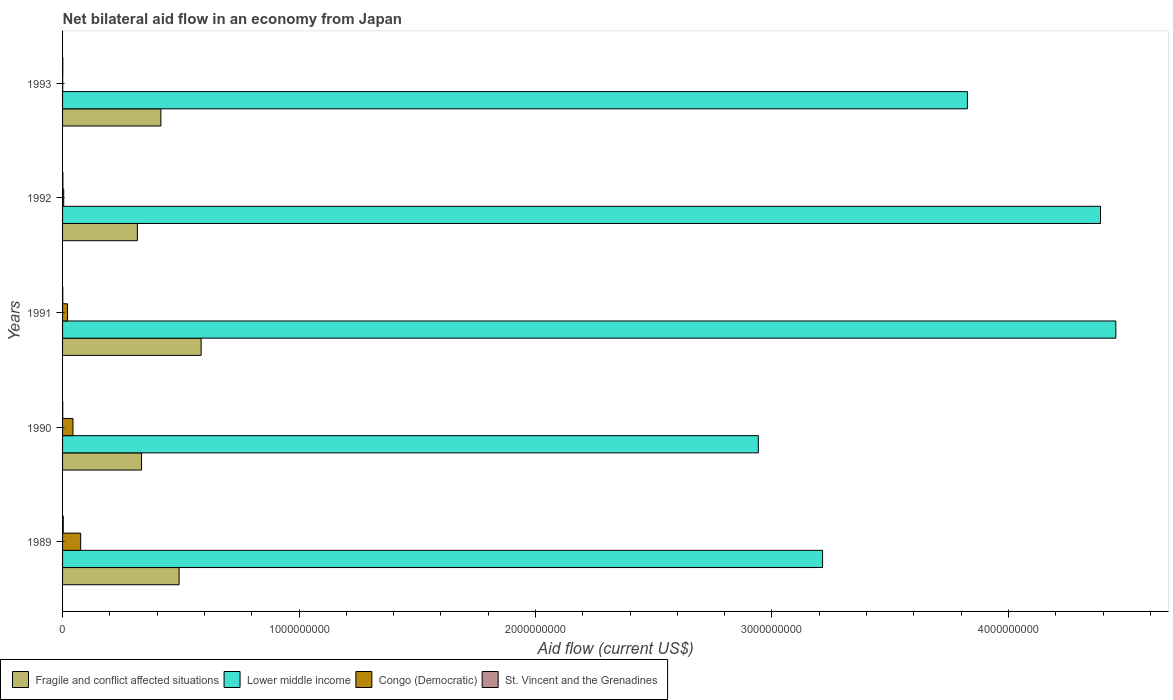How many different coloured bars are there?
Your answer should be compact. 4. How many groups of bars are there?
Offer a terse response. 5. Are the number of bars per tick equal to the number of legend labels?
Your answer should be very brief. Yes. Are the number of bars on each tick of the Y-axis equal?
Your answer should be compact. Yes. In how many cases, is the number of bars for a given year not equal to the number of legend labels?
Keep it short and to the point. 0. What is the net bilateral aid flow in Lower middle income in 1993?
Make the answer very short. 3.83e+09. Across all years, what is the maximum net bilateral aid flow in Congo (Democratic)?
Offer a terse response. 7.66e+07. Across all years, what is the minimum net bilateral aid flow in Fragile and conflict affected situations?
Your answer should be very brief. 3.16e+08. What is the total net bilateral aid flow in Congo (Democratic) in the graph?
Offer a very short reply. 1.47e+08. What is the difference between the net bilateral aid flow in Fragile and conflict affected situations in 1989 and that in 1993?
Your response must be concise. 7.71e+07. What is the difference between the net bilateral aid flow in Congo (Democratic) in 1990 and the net bilateral aid flow in St. Vincent and the Grenadines in 1993?
Your answer should be compact. 4.31e+07. What is the average net bilateral aid flow in Fragile and conflict affected situations per year?
Provide a succinct answer. 4.29e+08. In the year 1990, what is the difference between the net bilateral aid flow in St. Vincent and the Grenadines and net bilateral aid flow in Fragile and conflict affected situations?
Provide a succinct answer. -3.33e+08. In how many years, is the net bilateral aid flow in Lower middle income greater than 4200000000 US$?
Your answer should be very brief. 2. What is the ratio of the net bilateral aid flow in Congo (Democratic) in 1990 to that in 1992?
Make the answer very short. 9.22. Is the net bilateral aid flow in St. Vincent and the Grenadines in 1990 less than that in 1993?
Give a very brief answer. Yes. Is the difference between the net bilateral aid flow in St. Vincent and the Grenadines in 1991 and 1993 greater than the difference between the net bilateral aid flow in Fragile and conflict affected situations in 1991 and 1993?
Give a very brief answer. No. What is the difference between the highest and the second highest net bilateral aid flow in Fragile and conflict affected situations?
Offer a very short reply. 9.31e+07. What is the difference between the highest and the lowest net bilateral aid flow in Fragile and conflict affected situations?
Provide a short and direct response. 2.70e+08. Is the sum of the net bilateral aid flow in Lower middle income in 1989 and 1993 greater than the maximum net bilateral aid flow in St. Vincent and the Grenadines across all years?
Your response must be concise. Yes. Is it the case that in every year, the sum of the net bilateral aid flow in St. Vincent and the Grenadines and net bilateral aid flow in Congo (Democratic) is greater than the sum of net bilateral aid flow in Fragile and conflict affected situations and net bilateral aid flow in Lower middle income?
Your response must be concise. No. What does the 3rd bar from the top in 1991 represents?
Give a very brief answer. Lower middle income. What does the 1st bar from the bottom in 1992 represents?
Provide a short and direct response. Fragile and conflict affected situations. How many bars are there?
Your answer should be compact. 20. What is the difference between two consecutive major ticks on the X-axis?
Offer a terse response. 1.00e+09. Does the graph contain any zero values?
Give a very brief answer. No. How many legend labels are there?
Ensure brevity in your answer.  4. What is the title of the graph?
Your answer should be compact. Net bilateral aid flow in an economy from Japan. Does "Sweden" appear as one of the legend labels in the graph?
Your response must be concise. No. What is the Aid flow (current US$) of Fragile and conflict affected situations in 1989?
Keep it short and to the point. 4.93e+08. What is the Aid flow (current US$) of Lower middle income in 1989?
Your answer should be compact. 3.21e+09. What is the Aid flow (current US$) of Congo (Democratic) in 1989?
Offer a very short reply. 7.66e+07. What is the Aid flow (current US$) in St. Vincent and the Grenadines in 1989?
Make the answer very short. 2.97e+06. What is the Aid flow (current US$) of Fragile and conflict affected situations in 1990?
Make the answer very short. 3.34e+08. What is the Aid flow (current US$) in Lower middle income in 1990?
Provide a short and direct response. 2.94e+09. What is the Aid flow (current US$) of Congo (Democratic) in 1990?
Keep it short and to the point. 4.41e+07. What is the Aid flow (current US$) of St. Vincent and the Grenadines in 1990?
Offer a very short reply. 8.00e+05. What is the Aid flow (current US$) in Fragile and conflict affected situations in 1991?
Your answer should be very brief. 5.86e+08. What is the Aid flow (current US$) of Lower middle income in 1991?
Offer a very short reply. 4.45e+09. What is the Aid flow (current US$) of Congo (Democratic) in 1991?
Your answer should be compact. 2.10e+07. What is the Aid flow (current US$) in St. Vincent and the Grenadines in 1991?
Keep it short and to the point. 8.90e+05. What is the Aid flow (current US$) of Fragile and conflict affected situations in 1992?
Your answer should be compact. 3.16e+08. What is the Aid flow (current US$) in Lower middle income in 1992?
Give a very brief answer. 4.39e+09. What is the Aid flow (current US$) in Congo (Democratic) in 1992?
Your answer should be compact. 4.78e+06. What is the Aid flow (current US$) of St. Vincent and the Grenadines in 1992?
Keep it short and to the point. 1.39e+06. What is the Aid flow (current US$) in Fragile and conflict affected situations in 1993?
Your response must be concise. 4.16e+08. What is the Aid flow (current US$) in Lower middle income in 1993?
Make the answer very short. 3.83e+09. What is the Aid flow (current US$) in Congo (Democratic) in 1993?
Ensure brevity in your answer.  5.10e+05. What is the Aid flow (current US$) in St. Vincent and the Grenadines in 1993?
Provide a succinct answer. 9.90e+05. Across all years, what is the maximum Aid flow (current US$) in Fragile and conflict affected situations?
Give a very brief answer. 5.86e+08. Across all years, what is the maximum Aid flow (current US$) of Lower middle income?
Keep it short and to the point. 4.45e+09. Across all years, what is the maximum Aid flow (current US$) of Congo (Democratic)?
Your answer should be compact. 7.66e+07. Across all years, what is the maximum Aid flow (current US$) in St. Vincent and the Grenadines?
Make the answer very short. 2.97e+06. Across all years, what is the minimum Aid flow (current US$) in Fragile and conflict affected situations?
Offer a terse response. 3.16e+08. Across all years, what is the minimum Aid flow (current US$) in Lower middle income?
Make the answer very short. 2.94e+09. Across all years, what is the minimum Aid flow (current US$) in Congo (Democratic)?
Your answer should be compact. 5.10e+05. Across all years, what is the minimum Aid flow (current US$) of St. Vincent and the Grenadines?
Offer a terse response. 8.00e+05. What is the total Aid flow (current US$) in Fragile and conflict affected situations in the graph?
Ensure brevity in your answer.  2.14e+09. What is the total Aid flow (current US$) in Lower middle income in the graph?
Offer a terse response. 1.88e+1. What is the total Aid flow (current US$) of Congo (Democratic) in the graph?
Make the answer very short. 1.47e+08. What is the total Aid flow (current US$) in St. Vincent and the Grenadines in the graph?
Make the answer very short. 7.04e+06. What is the difference between the Aid flow (current US$) in Fragile and conflict affected situations in 1989 and that in 1990?
Offer a terse response. 1.59e+08. What is the difference between the Aid flow (current US$) in Lower middle income in 1989 and that in 1990?
Offer a very short reply. 2.72e+08. What is the difference between the Aid flow (current US$) in Congo (Democratic) in 1989 and that in 1990?
Give a very brief answer. 3.25e+07. What is the difference between the Aid flow (current US$) of St. Vincent and the Grenadines in 1989 and that in 1990?
Make the answer very short. 2.17e+06. What is the difference between the Aid flow (current US$) of Fragile and conflict affected situations in 1989 and that in 1991?
Your response must be concise. -9.31e+07. What is the difference between the Aid flow (current US$) in Lower middle income in 1989 and that in 1991?
Provide a short and direct response. -1.24e+09. What is the difference between the Aid flow (current US$) of Congo (Democratic) in 1989 and that in 1991?
Your response must be concise. 5.55e+07. What is the difference between the Aid flow (current US$) of St. Vincent and the Grenadines in 1989 and that in 1991?
Keep it short and to the point. 2.08e+06. What is the difference between the Aid flow (current US$) in Fragile and conflict affected situations in 1989 and that in 1992?
Ensure brevity in your answer.  1.77e+08. What is the difference between the Aid flow (current US$) of Lower middle income in 1989 and that in 1992?
Offer a very short reply. -1.18e+09. What is the difference between the Aid flow (current US$) of Congo (Democratic) in 1989 and that in 1992?
Ensure brevity in your answer.  7.18e+07. What is the difference between the Aid flow (current US$) of St. Vincent and the Grenadines in 1989 and that in 1992?
Make the answer very short. 1.58e+06. What is the difference between the Aid flow (current US$) of Fragile and conflict affected situations in 1989 and that in 1993?
Offer a terse response. 7.71e+07. What is the difference between the Aid flow (current US$) in Lower middle income in 1989 and that in 1993?
Make the answer very short. -6.12e+08. What is the difference between the Aid flow (current US$) of Congo (Democratic) in 1989 and that in 1993?
Your answer should be compact. 7.60e+07. What is the difference between the Aid flow (current US$) of St. Vincent and the Grenadines in 1989 and that in 1993?
Give a very brief answer. 1.98e+06. What is the difference between the Aid flow (current US$) in Fragile and conflict affected situations in 1990 and that in 1991?
Give a very brief answer. -2.52e+08. What is the difference between the Aid flow (current US$) in Lower middle income in 1990 and that in 1991?
Offer a very short reply. -1.51e+09. What is the difference between the Aid flow (current US$) in Congo (Democratic) in 1990 and that in 1991?
Your answer should be compact. 2.31e+07. What is the difference between the Aid flow (current US$) of Fragile and conflict affected situations in 1990 and that in 1992?
Your answer should be compact. 1.76e+07. What is the difference between the Aid flow (current US$) in Lower middle income in 1990 and that in 1992?
Make the answer very short. -1.45e+09. What is the difference between the Aid flow (current US$) of Congo (Democratic) in 1990 and that in 1992?
Keep it short and to the point. 3.93e+07. What is the difference between the Aid flow (current US$) in St. Vincent and the Grenadines in 1990 and that in 1992?
Offer a terse response. -5.90e+05. What is the difference between the Aid flow (current US$) in Fragile and conflict affected situations in 1990 and that in 1993?
Ensure brevity in your answer.  -8.18e+07. What is the difference between the Aid flow (current US$) in Lower middle income in 1990 and that in 1993?
Your answer should be very brief. -8.84e+08. What is the difference between the Aid flow (current US$) of Congo (Democratic) in 1990 and that in 1993?
Your answer should be very brief. 4.36e+07. What is the difference between the Aid flow (current US$) of Fragile and conflict affected situations in 1991 and that in 1992?
Ensure brevity in your answer.  2.70e+08. What is the difference between the Aid flow (current US$) of Lower middle income in 1991 and that in 1992?
Your response must be concise. 6.48e+07. What is the difference between the Aid flow (current US$) in Congo (Democratic) in 1991 and that in 1992?
Give a very brief answer. 1.62e+07. What is the difference between the Aid flow (current US$) of St. Vincent and the Grenadines in 1991 and that in 1992?
Provide a short and direct response. -5.00e+05. What is the difference between the Aid flow (current US$) in Fragile and conflict affected situations in 1991 and that in 1993?
Your answer should be very brief. 1.70e+08. What is the difference between the Aid flow (current US$) in Lower middle income in 1991 and that in 1993?
Your answer should be very brief. 6.28e+08. What is the difference between the Aid flow (current US$) of Congo (Democratic) in 1991 and that in 1993?
Your response must be concise. 2.05e+07. What is the difference between the Aid flow (current US$) of St. Vincent and the Grenadines in 1991 and that in 1993?
Ensure brevity in your answer.  -1.00e+05. What is the difference between the Aid flow (current US$) in Fragile and conflict affected situations in 1992 and that in 1993?
Your answer should be compact. -9.94e+07. What is the difference between the Aid flow (current US$) in Lower middle income in 1992 and that in 1993?
Offer a very short reply. 5.63e+08. What is the difference between the Aid flow (current US$) in Congo (Democratic) in 1992 and that in 1993?
Your answer should be very brief. 4.27e+06. What is the difference between the Aid flow (current US$) in St. Vincent and the Grenadines in 1992 and that in 1993?
Provide a succinct answer. 4.00e+05. What is the difference between the Aid flow (current US$) in Fragile and conflict affected situations in 1989 and the Aid flow (current US$) in Lower middle income in 1990?
Provide a short and direct response. -2.45e+09. What is the difference between the Aid flow (current US$) of Fragile and conflict affected situations in 1989 and the Aid flow (current US$) of Congo (Democratic) in 1990?
Offer a terse response. 4.49e+08. What is the difference between the Aid flow (current US$) in Fragile and conflict affected situations in 1989 and the Aid flow (current US$) in St. Vincent and the Grenadines in 1990?
Ensure brevity in your answer.  4.92e+08. What is the difference between the Aid flow (current US$) in Lower middle income in 1989 and the Aid flow (current US$) in Congo (Democratic) in 1990?
Your response must be concise. 3.17e+09. What is the difference between the Aid flow (current US$) of Lower middle income in 1989 and the Aid flow (current US$) of St. Vincent and the Grenadines in 1990?
Keep it short and to the point. 3.21e+09. What is the difference between the Aid flow (current US$) in Congo (Democratic) in 1989 and the Aid flow (current US$) in St. Vincent and the Grenadines in 1990?
Offer a terse response. 7.58e+07. What is the difference between the Aid flow (current US$) of Fragile and conflict affected situations in 1989 and the Aid flow (current US$) of Lower middle income in 1991?
Offer a very short reply. -3.96e+09. What is the difference between the Aid flow (current US$) of Fragile and conflict affected situations in 1989 and the Aid flow (current US$) of Congo (Democratic) in 1991?
Your answer should be very brief. 4.72e+08. What is the difference between the Aid flow (current US$) of Fragile and conflict affected situations in 1989 and the Aid flow (current US$) of St. Vincent and the Grenadines in 1991?
Give a very brief answer. 4.92e+08. What is the difference between the Aid flow (current US$) of Lower middle income in 1989 and the Aid flow (current US$) of Congo (Democratic) in 1991?
Give a very brief answer. 3.19e+09. What is the difference between the Aid flow (current US$) in Lower middle income in 1989 and the Aid flow (current US$) in St. Vincent and the Grenadines in 1991?
Make the answer very short. 3.21e+09. What is the difference between the Aid flow (current US$) in Congo (Democratic) in 1989 and the Aid flow (current US$) in St. Vincent and the Grenadines in 1991?
Ensure brevity in your answer.  7.57e+07. What is the difference between the Aid flow (current US$) of Fragile and conflict affected situations in 1989 and the Aid flow (current US$) of Lower middle income in 1992?
Provide a short and direct response. -3.90e+09. What is the difference between the Aid flow (current US$) in Fragile and conflict affected situations in 1989 and the Aid flow (current US$) in Congo (Democratic) in 1992?
Ensure brevity in your answer.  4.88e+08. What is the difference between the Aid flow (current US$) of Fragile and conflict affected situations in 1989 and the Aid flow (current US$) of St. Vincent and the Grenadines in 1992?
Your response must be concise. 4.91e+08. What is the difference between the Aid flow (current US$) of Lower middle income in 1989 and the Aid flow (current US$) of Congo (Democratic) in 1992?
Your answer should be compact. 3.21e+09. What is the difference between the Aid flow (current US$) of Lower middle income in 1989 and the Aid flow (current US$) of St. Vincent and the Grenadines in 1992?
Provide a short and direct response. 3.21e+09. What is the difference between the Aid flow (current US$) in Congo (Democratic) in 1989 and the Aid flow (current US$) in St. Vincent and the Grenadines in 1992?
Your answer should be compact. 7.52e+07. What is the difference between the Aid flow (current US$) in Fragile and conflict affected situations in 1989 and the Aid flow (current US$) in Lower middle income in 1993?
Offer a terse response. -3.33e+09. What is the difference between the Aid flow (current US$) of Fragile and conflict affected situations in 1989 and the Aid flow (current US$) of Congo (Democratic) in 1993?
Keep it short and to the point. 4.92e+08. What is the difference between the Aid flow (current US$) of Fragile and conflict affected situations in 1989 and the Aid flow (current US$) of St. Vincent and the Grenadines in 1993?
Keep it short and to the point. 4.92e+08. What is the difference between the Aid flow (current US$) in Lower middle income in 1989 and the Aid flow (current US$) in Congo (Democratic) in 1993?
Provide a short and direct response. 3.21e+09. What is the difference between the Aid flow (current US$) in Lower middle income in 1989 and the Aid flow (current US$) in St. Vincent and the Grenadines in 1993?
Provide a succinct answer. 3.21e+09. What is the difference between the Aid flow (current US$) of Congo (Democratic) in 1989 and the Aid flow (current US$) of St. Vincent and the Grenadines in 1993?
Offer a very short reply. 7.56e+07. What is the difference between the Aid flow (current US$) of Fragile and conflict affected situations in 1990 and the Aid flow (current US$) of Lower middle income in 1991?
Make the answer very short. -4.12e+09. What is the difference between the Aid flow (current US$) in Fragile and conflict affected situations in 1990 and the Aid flow (current US$) in Congo (Democratic) in 1991?
Your response must be concise. 3.13e+08. What is the difference between the Aid flow (current US$) of Fragile and conflict affected situations in 1990 and the Aid flow (current US$) of St. Vincent and the Grenadines in 1991?
Your answer should be very brief. 3.33e+08. What is the difference between the Aid flow (current US$) of Lower middle income in 1990 and the Aid flow (current US$) of Congo (Democratic) in 1991?
Offer a terse response. 2.92e+09. What is the difference between the Aid flow (current US$) in Lower middle income in 1990 and the Aid flow (current US$) in St. Vincent and the Grenadines in 1991?
Keep it short and to the point. 2.94e+09. What is the difference between the Aid flow (current US$) of Congo (Democratic) in 1990 and the Aid flow (current US$) of St. Vincent and the Grenadines in 1991?
Keep it short and to the point. 4.32e+07. What is the difference between the Aid flow (current US$) of Fragile and conflict affected situations in 1990 and the Aid flow (current US$) of Lower middle income in 1992?
Keep it short and to the point. -4.06e+09. What is the difference between the Aid flow (current US$) of Fragile and conflict affected situations in 1990 and the Aid flow (current US$) of Congo (Democratic) in 1992?
Give a very brief answer. 3.29e+08. What is the difference between the Aid flow (current US$) of Fragile and conflict affected situations in 1990 and the Aid flow (current US$) of St. Vincent and the Grenadines in 1992?
Your answer should be very brief. 3.33e+08. What is the difference between the Aid flow (current US$) of Lower middle income in 1990 and the Aid flow (current US$) of Congo (Democratic) in 1992?
Provide a succinct answer. 2.94e+09. What is the difference between the Aid flow (current US$) of Lower middle income in 1990 and the Aid flow (current US$) of St. Vincent and the Grenadines in 1992?
Keep it short and to the point. 2.94e+09. What is the difference between the Aid flow (current US$) of Congo (Democratic) in 1990 and the Aid flow (current US$) of St. Vincent and the Grenadines in 1992?
Offer a very short reply. 4.27e+07. What is the difference between the Aid flow (current US$) in Fragile and conflict affected situations in 1990 and the Aid flow (current US$) in Lower middle income in 1993?
Your answer should be compact. -3.49e+09. What is the difference between the Aid flow (current US$) in Fragile and conflict affected situations in 1990 and the Aid flow (current US$) in Congo (Democratic) in 1993?
Offer a terse response. 3.33e+08. What is the difference between the Aid flow (current US$) of Fragile and conflict affected situations in 1990 and the Aid flow (current US$) of St. Vincent and the Grenadines in 1993?
Keep it short and to the point. 3.33e+08. What is the difference between the Aid flow (current US$) in Lower middle income in 1990 and the Aid flow (current US$) in Congo (Democratic) in 1993?
Your answer should be compact. 2.94e+09. What is the difference between the Aid flow (current US$) in Lower middle income in 1990 and the Aid flow (current US$) in St. Vincent and the Grenadines in 1993?
Ensure brevity in your answer.  2.94e+09. What is the difference between the Aid flow (current US$) in Congo (Democratic) in 1990 and the Aid flow (current US$) in St. Vincent and the Grenadines in 1993?
Make the answer very short. 4.31e+07. What is the difference between the Aid flow (current US$) of Fragile and conflict affected situations in 1991 and the Aid flow (current US$) of Lower middle income in 1992?
Provide a short and direct response. -3.80e+09. What is the difference between the Aid flow (current US$) of Fragile and conflict affected situations in 1991 and the Aid flow (current US$) of Congo (Democratic) in 1992?
Provide a short and direct response. 5.81e+08. What is the difference between the Aid flow (current US$) in Fragile and conflict affected situations in 1991 and the Aid flow (current US$) in St. Vincent and the Grenadines in 1992?
Keep it short and to the point. 5.85e+08. What is the difference between the Aid flow (current US$) of Lower middle income in 1991 and the Aid flow (current US$) of Congo (Democratic) in 1992?
Give a very brief answer. 4.45e+09. What is the difference between the Aid flow (current US$) in Lower middle income in 1991 and the Aid flow (current US$) in St. Vincent and the Grenadines in 1992?
Your answer should be compact. 4.45e+09. What is the difference between the Aid flow (current US$) in Congo (Democratic) in 1991 and the Aid flow (current US$) in St. Vincent and the Grenadines in 1992?
Provide a short and direct response. 1.96e+07. What is the difference between the Aid flow (current US$) in Fragile and conflict affected situations in 1991 and the Aid flow (current US$) in Lower middle income in 1993?
Offer a terse response. -3.24e+09. What is the difference between the Aid flow (current US$) of Fragile and conflict affected situations in 1991 and the Aid flow (current US$) of Congo (Democratic) in 1993?
Your answer should be compact. 5.85e+08. What is the difference between the Aid flow (current US$) in Fragile and conflict affected situations in 1991 and the Aid flow (current US$) in St. Vincent and the Grenadines in 1993?
Provide a short and direct response. 5.85e+08. What is the difference between the Aid flow (current US$) of Lower middle income in 1991 and the Aid flow (current US$) of Congo (Democratic) in 1993?
Offer a terse response. 4.45e+09. What is the difference between the Aid flow (current US$) of Lower middle income in 1991 and the Aid flow (current US$) of St. Vincent and the Grenadines in 1993?
Provide a succinct answer. 4.45e+09. What is the difference between the Aid flow (current US$) of Congo (Democratic) in 1991 and the Aid flow (current US$) of St. Vincent and the Grenadines in 1993?
Give a very brief answer. 2.00e+07. What is the difference between the Aid flow (current US$) of Fragile and conflict affected situations in 1992 and the Aid flow (current US$) of Lower middle income in 1993?
Make the answer very short. -3.51e+09. What is the difference between the Aid flow (current US$) in Fragile and conflict affected situations in 1992 and the Aid flow (current US$) in Congo (Democratic) in 1993?
Provide a short and direct response. 3.16e+08. What is the difference between the Aid flow (current US$) of Fragile and conflict affected situations in 1992 and the Aid flow (current US$) of St. Vincent and the Grenadines in 1993?
Your answer should be compact. 3.15e+08. What is the difference between the Aid flow (current US$) in Lower middle income in 1992 and the Aid flow (current US$) in Congo (Democratic) in 1993?
Make the answer very short. 4.39e+09. What is the difference between the Aid flow (current US$) of Lower middle income in 1992 and the Aid flow (current US$) of St. Vincent and the Grenadines in 1993?
Offer a terse response. 4.39e+09. What is the difference between the Aid flow (current US$) in Congo (Democratic) in 1992 and the Aid flow (current US$) in St. Vincent and the Grenadines in 1993?
Your answer should be compact. 3.79e+06. What is the average Aid flow (current US$) in Fragile and conflict affected situations per year?
Your response must be concise. 4.29e+08. What is the average Aid flow (current US$) in Lower middle income per year?
Your answer should be compact. 3.77e+09. What is the average Aid flow (current US$) in Congo (Democratic) per year?
Make the answer very short. 2.94e+07. What is the average Aid flow (current US$) in St. Vincent and the Grenadines per year?
Your answer should be compact. 1.41e+06. In the year 1989, what is the difference between the Aid flow (current US$) of Fragile and conflict affected situations and Aid flow (current US$) of Lower middle income?
Provide a succinct answer. -2.72e+09. In the year 1989, what is the difference between the Aid flow (current US$) of Fragile and conflict affected situations and Aid flow (current US$) of Congo (Democratic)?
Your response must be concise. 4.16e+08. In the year 1989, what is the difference between the Aid flow (current US$) in Fragile and conflict affected situations and Aid flow (current US$) in St. Vincent and the Grenadines?
Provide a short and direct response. 4.90e+08. In the year 1989, what is the difference between the Aid flow (current US$) in Lower middle income and Aid flow (current US$) in Congo (Democratic)?
Ensure brevity in your answer.  3.14e+09. In the year 1989, what is the difference between the Aid flow (current US$) in Lower middle income and Aid flow (current US$) in St. Vincent and the Grenadines?
Your answer should be very brief. 3.21e+09. In the year 1989, what is the difference between the Aid flow (current US$) of Congo (Democratic) and Aid flow (current US$) of St. Vincent and the Grenadines?
Keep it short and to the point. 7.36e+07. In the year 1990, what is the difference between the Aid flow (current US$) in Fragile and conflict affected situations and Aid flow (current US$) in Lower middle income?
Your response must be concise. -2.61e+09. In the year 1990, what is the difference between the Aid flow (current US$) of Fragile and conflict affected situations and Aid flow (current US$) of Congo (Democratic)?
Your response must be concise. 2.90e+08. In the year 1990, what is the difference between the Aid flow (current US$) in Fragile and conflict affected situations and Aid flow (current US$) in St. Vincent and the Grenadines?
Provide a short and direct response. 3.33e+08. In the year 1990, what is the difference between the Aid flow (current US$) of Lower middle income and Aid flow (current US$) of Congo (Democratic)?
Provide a succinct answer. 2.90e+09. In the year 1990, what is the difference between the Aid flow (current US$) of Lower middle income and Aid flow (current US$) of St. Vincent and the Grenadines?
Give a very brief answer. 2.94e+09. In the year 1990, what is the difference between the Aid flow (current US$) of Congo (Democratic) and Aid flow (current US$) of St. Vincent and the Grenadines?
Give a very brief answer. 4.33e+07. In the year 1991, what is the difference between the Aid flow (current US$) of Fragile and conflict affected situations and Aid flow (current US$) of Lower middle income?
Give a very brief answer. -3.87e+09. In the year 1991, what is the difference between the Aid flow (current US$) in Fragile and conflict affected situations and Aid flow (current US$) in Congo (Democratic)?
Give a very brief answer. 5.65e+08. In the year 1991, what is the difference between the Aid flow (current US$) in Fragile and conflict affected situations and Aid flow (current US$) in St. Vincent and the Grenadines?
Give a very brief answer. 5.85e+08. In the year 1991, what is the difference between the Aid flow (current US$) in Lower middle income and Aid flow (current US$) in Congo (Democratic)?
Offer a very short reply. 4.43e+09. In the year 1991, what is the difference between the Aid flow (current US$) of Lower middle income and Aid flow (current US$) of St. Vincent and the Grenadines?
Your answer should be compact. 4.45e+09. In the year 1991, what is the difference between the Aid flow (current US$) of Congo (Democratic) and Aid flow (current US$) of St. Vincent and the Grenadines?
Provide a short and direct response. 2.01e+07. In the year 1992, what is the difference between the Aid flow (current US$) of Fragile and conflict affected situations and Aid flow (current US$) of Lower middle income?
Your answer should be very brief. -4.07e+09. In the year 1992, what is the difference between the Aid flow (current US$) in Fragile and conflict affected situations and Aid flow (current US$) in Congo (Democratic)?
Keep it short and to the point. 3.12e+08. In the year 1992, what is the difference between the Aid flow (current US$) of Fragile and conflict affected situations and Aid flow (current US$) of St. Vincent and the Grenadines?
Your answer should be very brief. 3.15e+08. In the year 1992, what is the difference between the Aid flow (current US$) of Lower middle income and Aid flow (current US$) of Congo (Democratic)?
Provide a succinct answer. 4.38e+09. In the year 1992, what is the difference between the Aid flow (current US$) in Lower middle income and Aid flow (current US$) in St. Vincent and the Grenadines?
Your answer should be very brief. 4.39e+09. In the year 1992, what is the difference between the Aid flow (current US$) of Congo (Democratic) and Aid flow (current US$) of St. Vincent and the Grenadines?
Offer a terse response. 3.39e+06. In the year 1993, what is the difference between the Aid flow (current US$) of Fragile and conflict affected situations and Aid flow (current US$) of Lower middle income?
Your answer should be compact. -3.41e+09. In the year 1993, what is the difference between the Aid flow (current US$) in Fragile and conflict affected situations and Aid flow (current US$) in Congo (Democratic)?
Your answer should be compact. 4.15e+08. In the year 1993, what is the difference between the Aid flow (current US$) in Fragile and conflict affected situations and Aid flow (current US$) in St. Vincent and the Grenadines?
Your answer should be compact. 4.15e+08. In the year 1993, what is the difference between the Aid flow (current US$) of Lower middle income and Aid flow (current US$) of Congo (Democratic)?
Keep it short and to the point. 3.83e+09. In the year 1993, what is the difference between the Aid flow (current US$) in Lower middle income and Aid flow (current US$) in St. Vincent and the Grenadines?
Provide a succinct answer. 3.83e+09. In the year 1993, what is the difference between the Aid flow (current US$) in Congo (Democratic) and Aid flow (current US$) in St. Vincent and the Grenadines?
Offer a terse response. -4.80e+05. What is the ratio of the Aid flow (current US$) of Fragile and conflict affected situations in 1989 to that in 1990?
Offer a very short reply. 1.48. What is the ratio of the Aid flow (current US$) in Lower middle income in 1989 to that in 1990?
Give a very brief answer. 1.09. What is the ratio of the Aid flow (current US$) of Congo (Democratic) in 1989 to that in 1990?
Offer a terse response. 1.74. What is the ratio of the Aid flow (current US$) of St. Vincent and the Grenadines in 1989 to that in 1990?
Make the answer very short. 3.71. What is the ratio of the Aid flow (current US$) of Fragile and conflict affected situations in 1989 to that in 1991?
Offer a terse response. 0.84. What is the ratio of the Aid flow (current US$) in Lower middle income in 1989 to that in 1991?
Give a very brief answer. 0.72. What is the ratio of the Aid flow (current US$) of Congo (Democratic) in 1989 to that in 1991?
Your response must be concise. 3.64. What is the ratio of the Aid flow (current US$) of St. Vincent and the Grenadines in 1989 to that in 1991?
Ensure brevity in your answer.  3.34. What is the ratio of the Aid flow (current US$) of Fragile and conflict affected situations in 1989 to that in 1992?
Provide a short and direct response. 1.56. What is the ratio of the Aid flow (current US$) of Lower middle income in 1989 to that in 1992?
Provide a succinct answer. 0.73. What is the ratio of the Aid flow (current US$) of Congo (Democratic) in 1989 to that in 1992?
Give a very brief answer. 16.02. What is the ratio of the Aid flow (current US$) in St. Vincent and the Grenadines in 1989 to that in 1992?
Ensure brevity in your answer.  2.14. What is the ratio of the Aid flow (current US$) of Fragile and conflict affected situations in 1989 to that in 1993?
Ensure brevity in your answer.  1.19. What is the ratio of the Aid flow (current US$) in Lower middle income in 1989 to that in 1993?
Offer a terse response. 0.84. What is the ratio of the Aid flow (current US$) of Congo (Democratic) in 1989 to that in 1993?
Provide a short and direct response. 150.12. What is the ratio of the Aid flow (current US$) of St. Vincent and the Grenadines in 1989 to that in 1993?
Your response must be concise. 3. What is the ratio of the Aid flow (current US$) of Fragile and conflict affected situations in 1990 to that in 1991?
Give a very brief answer. 0.57. What is the ratio of the Aid flow (current US$) of Lower middle income in 1990 to that in 1991?
Give a very brief answer. 0.66. What is the ratio of the Aid flow (current US$) in Congo (Democratic) in 1990 to that in 1991?
Offer a very short reply. 2.1. What is the ratio of the Aid flow (current US$) in St. Vincent and the Grenadines in 1990 to that in 1991?
Provide a short and direct response. 0.9. What is the ratio of the Aid flow (current US$) of Fragile and conflict affected situations in 1990 to that in 1992?
Offer a terse response. 1.06. What is the ratio of the Aid flow (current US$) in Lower middle income in 1990 to that in 1992?
Your answer should be compact. 0.67. What is the ratio of the Aid flow (current US$) in Congo (Democratic) in 1990 to that in 1992?
Keep it short and to the point. 9.22. What is the ratio of the Aid flow (current US$) of St. Vincent and the Grenadines in 1990 to that in 1992?
Provide a succinct answer. 0.58. What is the ratio of the Aid flow (current US$) of Fragile and conflict affected situations in 1990 to that in 1993?
Provide a short and direct response. 0.8. What is the ratio of the Aid flow (current US$) in Lower middle income in 1990 to that in 1993?
Provide a succinct answer. 0.77. What is the ratio of the Aid flow (current US$) of Congo (Democratic) in 1990 to that in 1993?
Provide a short and direct response. 86.45. What is the ratio of the Aid flow (current US$) in St. Vincent and the Grenadines in 1990 to that in 1993?
Your answer should be very brief. 0.81. What is the ratio of the Aid flow (current US$) of Fragile and conflict affected situations in 1991 to that in 1992?
Offer a very short reply. 1.85. What is the ratio of the Aid flow (current US$) in Lower middle income in 1991 to that in 1992?
Make the answer very short. 1.01. What is the ratio of the Aid flow (current US$) of Congo (Democratic) in 1991 to that in 1992?
Your answer should be very brief. 4.4. What is the ratio of the Aid flow (current US$) of St. Vincent and the Grenadines in 1991 to that in 1992?
Your answer should be very brief. 0.64. What is the ratio of the Aid flow (current US$) of Fragile and conflict affected situations in 1991 to that in 1993?
Your response must be concise. 1.41. What is the ratio of the Aid flow (current US$) of Lower middle income in 1991 to that in 1993?
Give a very brief answer. 1.16. What is the ratio of the Aid flow (current US$) in Congo (Democratic) in 1991 to that in 1993?
Your response must be concise. 41.22. What is the ratio of the Aid flow (current US$) in St. Vincent and the Grenadines in 1991 to that in 1993?
Provide a short and direct response. 0.9. What is the ratio of the Aid flow (current US$) of Fragile and conflict affected situations in 1992 to that in 1993?
Ensure brevity in your answer.  0.76. What is the ratio of the Aid flow (current US$) in Lower middle income in 1992 to that in 1993?
Your answer should be very brief. 1.15. What is the ratio of the Aid flow (current US$) in Congo (Democratic) in 1992 to that in 1993?
Keep it short and to the point. 9.37. What is the ratio of the Aid flow (current US$) of St. Vincent and the Grenadines in 1992 to that in 1993?
Your answer should be compact. 1.4. What is the difference between the highest and the second highest Aid flow (current US$) of Fragile and conflict affected situations?
Your response must be concise. 9.31e+07. What is the difference between the highest and the second highest Aid flow (current US$) in Lower middle income?
Your answer should be compact. 6.48e+07. What is the difference between the highest and the second highest Aid flow (current US$) of Congo (Democratic)?
Offer a terse response. 3.25e+07. What is the difference between the highest and the second highest Aid flow (current US$) in St. Vincent and the Grenadines?
Offer a very short reply. 1.58e+06. What is the difference between the highest and the lowest Aid flow (current US$) in Fragile and conflict affected situations?
Give a very brief answer. 2.70e+08. What is the difference between the highest and the lowest Aid flow (current US$) in Lower middle income?
Give a very brief answer. 1.51e+09. What is the difference between the highest and the lowest Aid flow (current US$) in Congo (Democratic)?
Offer a very short reply. 7.60e+07. What is the difference between the highest and the lowest Aid flow (current US$) of St. Vincent and the Grenadines?
Keep it short and to the point. 2.17e+06. 